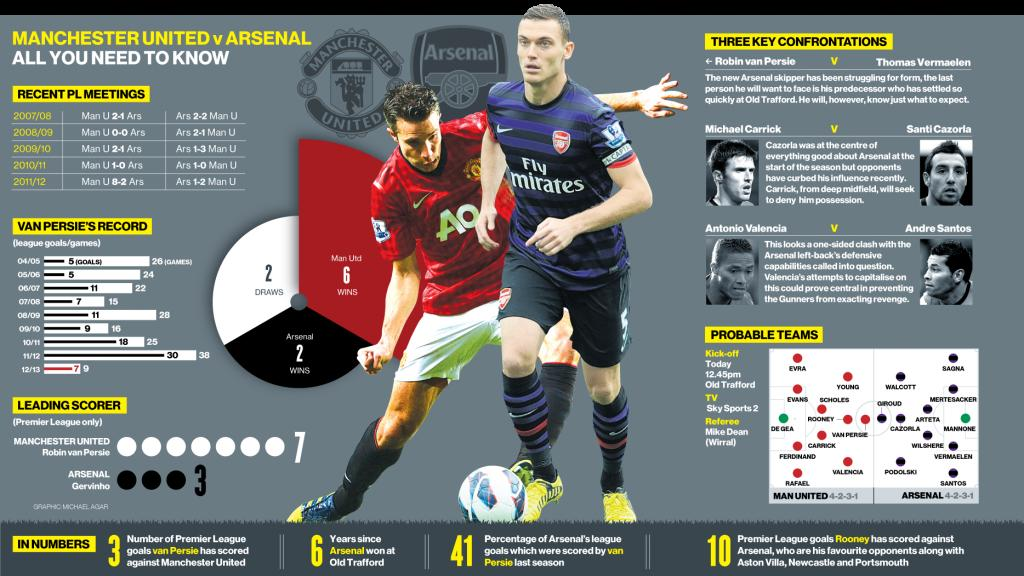Outline some significant characteristics in this image. With the two probable goalkeepers being De Gea and Mannone, the identity of the two goalkeepers for the team is now clear. The color of the soccer player's shoes, as seen in the photograph, is yellow. Wayne Rooney has faced several formidable opponents throughout his career, including Newcastle United and Portsmouth. In addition to these teams, Arsenal and Aston Villa are among his other favorite opponents. Below the logo on the blue T-shirt, the text 'Fly Mirates' can be seen. 